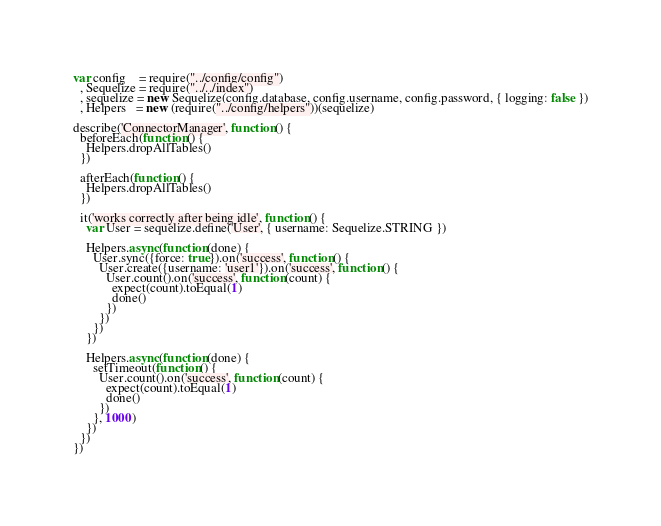<code> <loc_0><loc_0><loc_500><loc_500><_JavaScript_>var config    = require("../config/config")
  , Sequelize = require("../../index")
  , sequelize = new Sequelize(config.database, config.username, config.password, { logging: false })
  , Helpers   = new (require("../config/helpers"))(sequelize)

describe('ConnectorManager', function() {
  beforeEach(function() {
    Helpers.dropAllTables()
  })

  afterEach(function() {
    Helpers.dropAllTables()
  })

  it('works correctly after being idle', function() {
    var User = sequelize.define('User', { username: Sequelize.STRING })

    Helpers.async(function(done) {
      User.sync({force: true}).on('success', function() {
        User.create({username: 'user1'}).on('success', function() {
          User.count().on('success', function(count) {
            expect(count).toEqual(1)
            done()
          })
        })
      })
    })

    Helpers.async(function(done) {
      setTimeout(function() {
        User.count().on('success', function(count) {
          expect(count).toEqual(1)
          done()
        })
      }, 1000)
    })
  })
})
</code> 